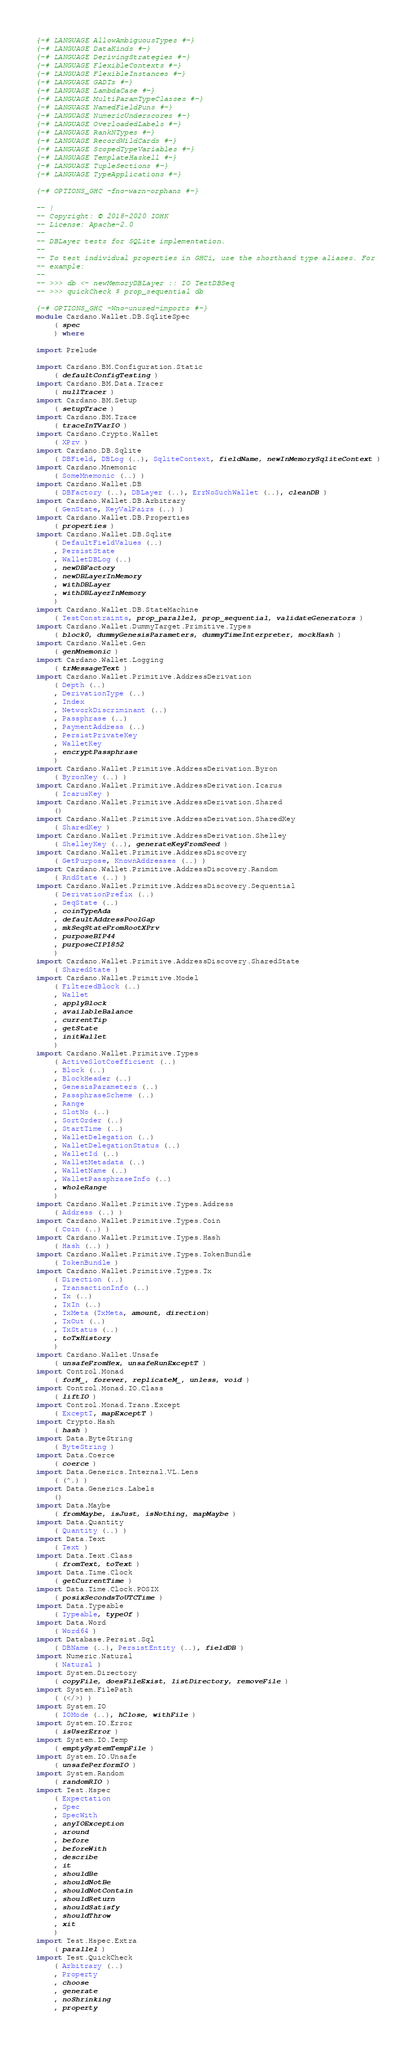<code> <loc_0><loc_0><loc_500><loc_500><_Haskell_>{-# LANGUAGE AllowAmbiguousTypes #-}
{-# LANGUAGE DataKinds #-}
{-# LANGUAGE DerivingStrategies #-}
{-# LANGUAGE FlexibleContexts #-}
{-# LANGUAGE FlexibleInstances #-}
{-# LANGUAGE GADTs #-}
{-# LANGUAGE LambdaCase #-}
{-# LANGUAGE MultiParamTypeClasses #-}
{-# LANGUAGE NamedFieldPuns #-}
{-# LANGUAGE NumericUnderscores #-}
{-# LANGUAGE OverloadedLabels #-}
{-# LANGUAGE RankNTypes #-}
{-# LANGUAGE RecordWildCards #-}
{-# LANGUAGE ScopedTypeVariables #-}
{-# LANGUAGE TemplateHaskell #-}
{-# LANGUAGE TupleSections #-}
{-# LANGUAGE TypeApplications #-}

{-# OPTIONS_GHC -fno-warn-orphans #-}

-- |
-- Copyright: © 2018-2020 IOHK
-- License: Apache-2.0
--
-- DBLayer tests for SQLite implementation.
--
-- To test individual properties in GHCi, use the shorthand type aliases. For
-- example:
--
-- >>> db <- newMemoryDBLayer :: IO TestDBSeq
-- >>> quickCheck $ prop_sequential db

{-# OPTIONS_GHC -Wno-unused-imports #-}
module Cardano.Wallet.DB.SqliteSpec
    ( spec
    ) where

import Prelude

import Cardano.BM.Configuration.Static
    ( defaultConfigTesting )
import Cardano.BM.Data.Tracer
    ( nullTracer )
import Cardano.BM.Setup
    ( setupTrace )
import Cardano.BM.Trace
    ( traceInTVarIO )
import Cardano.Crypto.Wallet
    ( XPrv )
import Cardano.DB.Sqlite
    ( DBField, DBLog (..), SqliteContext, fieldName, newInMemorySqliteContext )
import Cardano.Mnemonic
    ( SomeMnemonic (..) )
import Cardano.Wallet.DB
    ( DBFactory (..), DBLayer (..), ErrNoSuchWallet (..), cleanDB )
import Cardano.Wallet.DB.Arbitrary
    ( GenState, KeyValPairs (..) )
import Cardano.Wallet.DB.Properties
    ( properties )
import Cardano.Wallet.DB.Sqlite
    ( DefaultFieldValues (..)
    , PersistState
    , WalletDBLog (..)
    , newDBFactory
    , newDBLayerInMemory
    , withDBLayer
    , withDBLayerInMemory
    )
import Cardano.Wallet.DB.StateMachine
    ( TestConstraints, prop_parallel, prop_sequential, validateGenerators )
import Cardano.Wallet.DummyTarget.Primitive.Types
    ( block0, dummyGenesisParameters, dummyTimeInterpreter, mockHash )
import Cardano.Wallet.Gen
    ( genMnemonic )
import Cardano.Wallet.Logging
    ( trMessageText )
import Cardano.Wallet.Primitive.AddressDerivation
    ( Depth (..)
    , DerivationType (..)
    , Index
    , NetworkDiscriminant (..)
    , Passphrase (..)
    , PaymentAddress (..)
    , PersistPrivateKey
    , WalletKey
    , encryptPassphrase
    )
import Cardano.Wallet.Primitive.AddressDerivation.Byron
    ( ByronKey (..) )
import Cardano.Wallet.Primitive.AddressDerivation.Icarus
    ( IcarusKey )
import Cardano.Wallet.Primitive.AddressDerivation.Shared
    ()
import Cardano.Wallet.Primitive.AddressDerivation.SharedKey
    ( SharedKey )
import Cardano.Wallet.Primitive.AddressDerivation.Shelley
    ( ShelleyKey (..), generateKeyFromSeed )
import Cardano.Wallet.Primitive.AddressDiscovery
    ( GetPurpose, KnownAddresses (..) )
import Cardano.Wallet.Primitive.AddressDiscovery.Random
    ( RndState (..) )
import Cardano.Wallet.Primitive.AddressDiscovery.Sequential
    ( DerivationPrefix (..)
    , SeqState (..)
    , coinTypeAda
    , defaultAddressPoolGap
    , mkSeqStateFromRootXPrv
    , purposeBIP44
    , purposeCIP1852
    )
import Cardano.Wallet.Primitive.AddressDiscovery.SharedState
    ( SharedState )
import Cardano.Wallet.Primitive.Model
    ( FilteredBlock (..)
    , Wallet
    , applyBlock
    , availableBalance
    , currentTip
    , getState
    , initWallet
    )
import Cardano.Wallet.Primitive.Types
    ( ActiveSlotCoefficient (..)
    , Block (..)
    , BlockHeader (..)
    , GenesisParameters (..)
    , PassphraseScheme (..)
    , Range
    , SlotNo (..)
    , SortOrder (..)
    , StartTime (..)
    , WalletDelegation (..)
    , WalletDelegationStatus (..)
    , WalletId (..)
    , WalletMetadata (..)
    , WalletName (..)
    , WalletPassphraseInfo (..)
    , wholeRange
    )
import Cardano.Wallet.Primitive.Types.Address
    ( Address (..) )
import Cardano.Wallet.Primitive.Types.Coin
    ( Coin (..) )
import Cardano.Wallet.Primitive.Types.Hash
    ( Hash (..) )
import Cardano.Wallet.Primitive.Types.TokenBundle
    ( TokenBundle )
import Cardano.Wallet.Primitive.Types.Tx
    ( Direction (..)
    , TransactionInfo (..)
    , Tx (..)
    , TxIn (..)
    , TxMeta (TxMeta, amount, direction)
    , TxOut (..)
    , TxStatus (..)
    , toTxHistory
    )
import Cardano.Wallet.Unsafe
    ( unsafeFromHex, unsafeRunExceptT )
import Control.Monad
    ( forM_, forever, replicateM_, unless, void )
import Control.Monad.IO.Class
    ( liftIO )
import Control.Monad.Trans.Except
    ( ExceptT, mapExceptT )
import Crypto.Hash
    ( hash )
import Data.ByteString
    ( ByteString )
import Data.Coerce
    ( coerce )
import Data.Generics.Internal.VL.Lens
    ( (^.) )
import Data.Generics.Labels
    ()
import Data.Maybe
    ( fromMaybe, isJust, isNothing, mapMaybe )
import Data.Quantity
    ( Quantity (..) )
import Data.Text
    ( Text )
import Data.Text.Class
    ( fromText, toText )
import Data.Time.Clock
    ( getCurrentTime )
import Data.Time.Clock.POSIX
    ( posixSecondsToUTCTime )
import Data.Typeable
    ( Typeable, typeOf )
import Data.Word
    ( Word64 )
import Database.Persist.Sql
    ( DBName (..), PersistEntity (..), fieldDB )
import Numeric.Natural
    ( Natural )
import System.Directory
    ( copyFile, doesFileExist, listDirectory, removeFile )
import System.FilePath
    ( (</>) )
import System.IO
    ( IOMode (..), hClose, withFile )
import System.IO.Error
    ( isUserError )
import System.IO.Temp
    ( emptySystemTempFile )
import System.IO.Unsafe
    ( unsafePerformIO )
import System.Random
    ( randomRIO )
import Test.Hspec
    ( Expectation
    , Spec
    , SpecWith
    , anyIOException
    , around
    , before
    , beforeWith
    , describe
    , it
    , shouldBe
    , shouldNotBe
    , shouldNotContain
    , shouldReturn
    , shouldSatisfy
    , shouldThrow
    , xit
    )
import Test.Hspec.Extra
    ( parallel )
import Test.QuickCheck
    ( Arbitrary (..)
    , Property
    , choose
    , generate
    , noShrinking
    , property</code> 